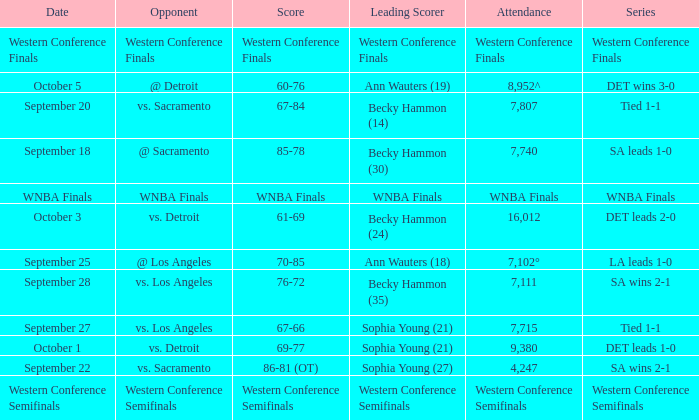What is the attendance of the western conference finals series? Western Conference Finals. 